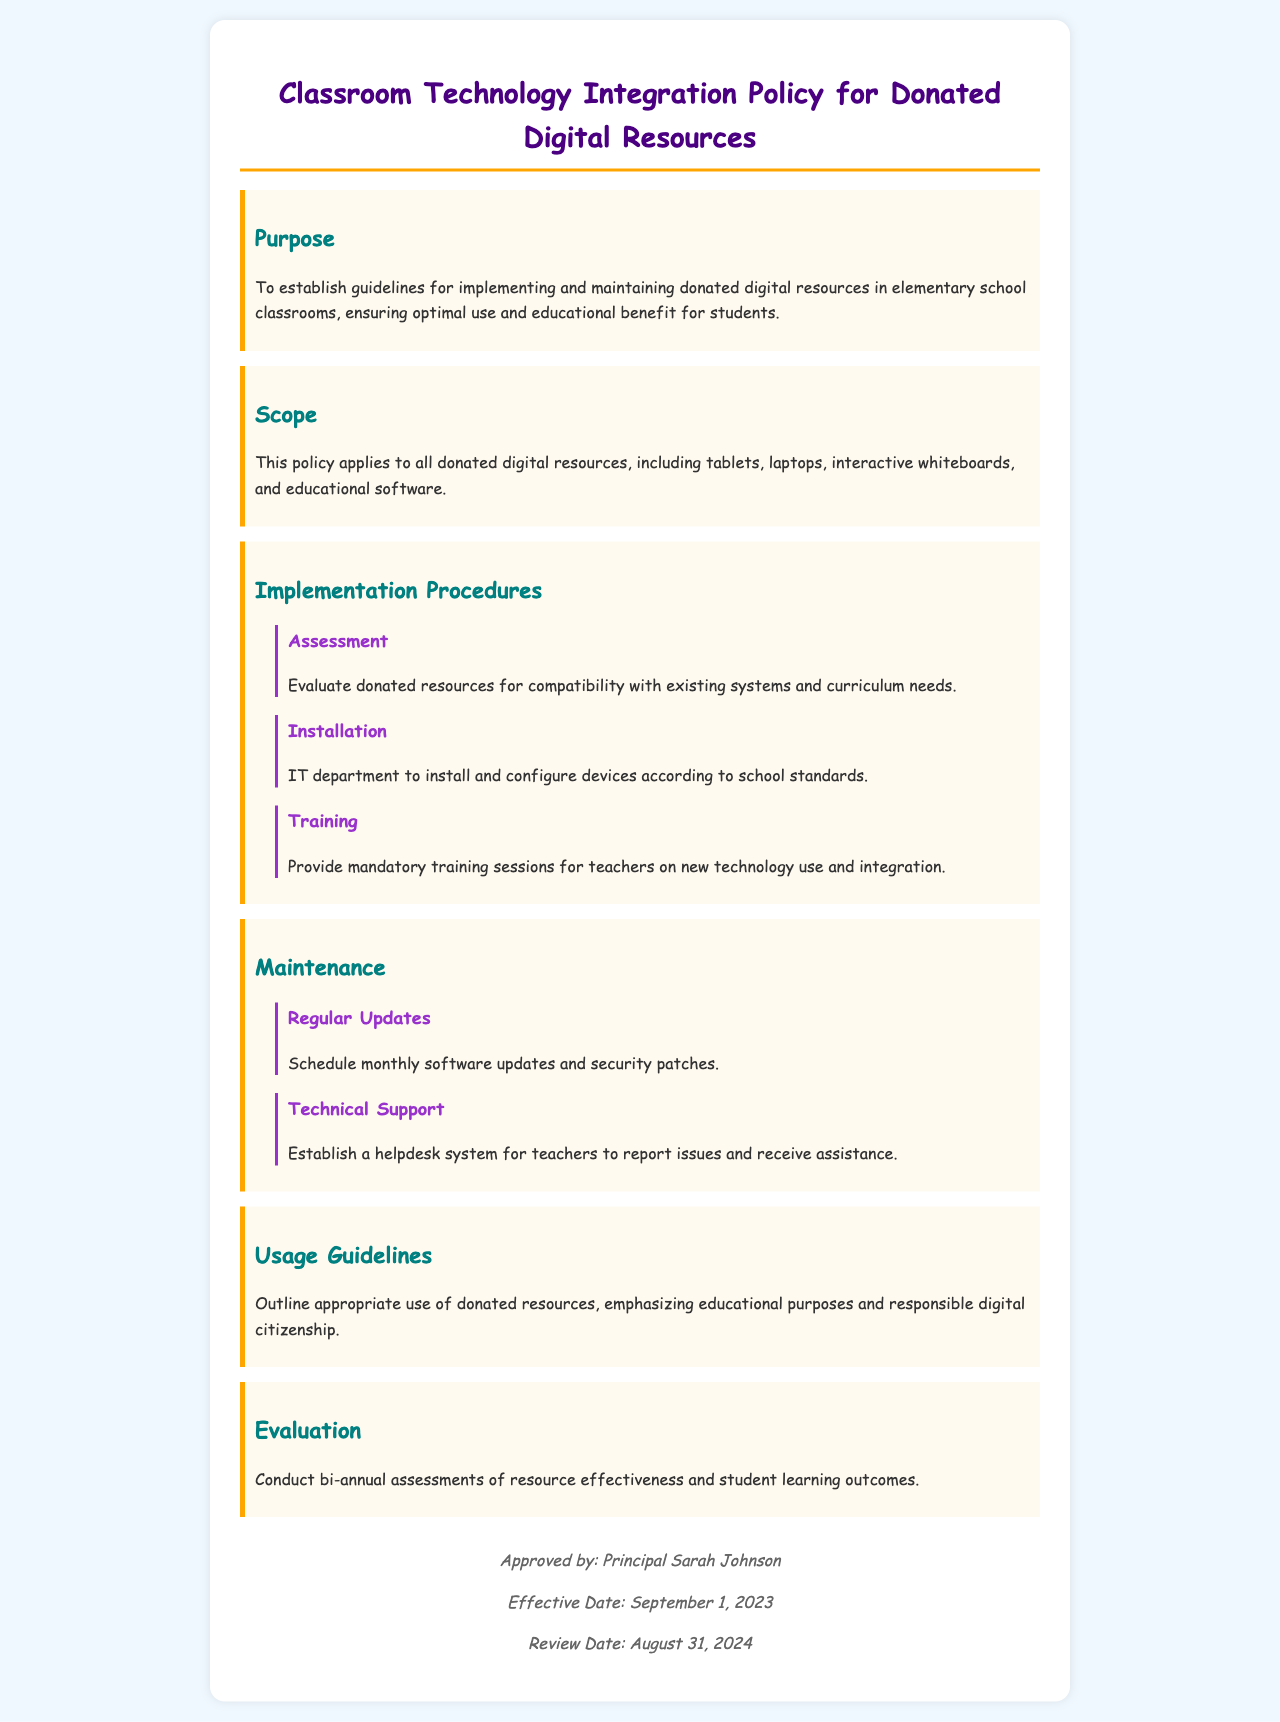What is the purpose of the policy? The purpose of the policy is to establish guidelines for implementing and maintaining donated digital resources in elementary school classrooms, ensuring optimal use and educational benefit for students.
Answer: To establish guidelines for implementing and maintaining donated digital resources in elementary school classrooms, ensuring optimal use and educational benefit for students Who approves the policy? The document states the approval is from Principal Sarah Johnson.
Answer: Principal Sarah Johnson When is the review date for the policy? The review date is mentioned in the footer of the document as a specific date.
Answer: August 31, 2024 What are the two main areas covered under maintenance? The maintenance section includes regular updates and technical support, highlighting the importance of these aspects.
Answer: Regular Updates and Technical Support How often are assessments conducted for resource effectiveness? The document specifies the frequency of the evaluations in the evaluation section.
Answer: Bi-annual What type of resources does the policy apply to? The scope of the policy indicates that it applies to a variety of digital resources, specifically mentioned in the document.
Answer: Donated digital resources, including tablets, laptops, interactive whiteboards, and educational software What is required before teachers can use the new technology? The implementation procedures specify that teachers must undergo a certain process prior to use.
Answer: Mandatory training sessions What is the main focus of the usage guidelines? The usage guidelines section underscores a specific approach towards the donated resources.
Answer: Educational purposes and responsible digital citizenship 